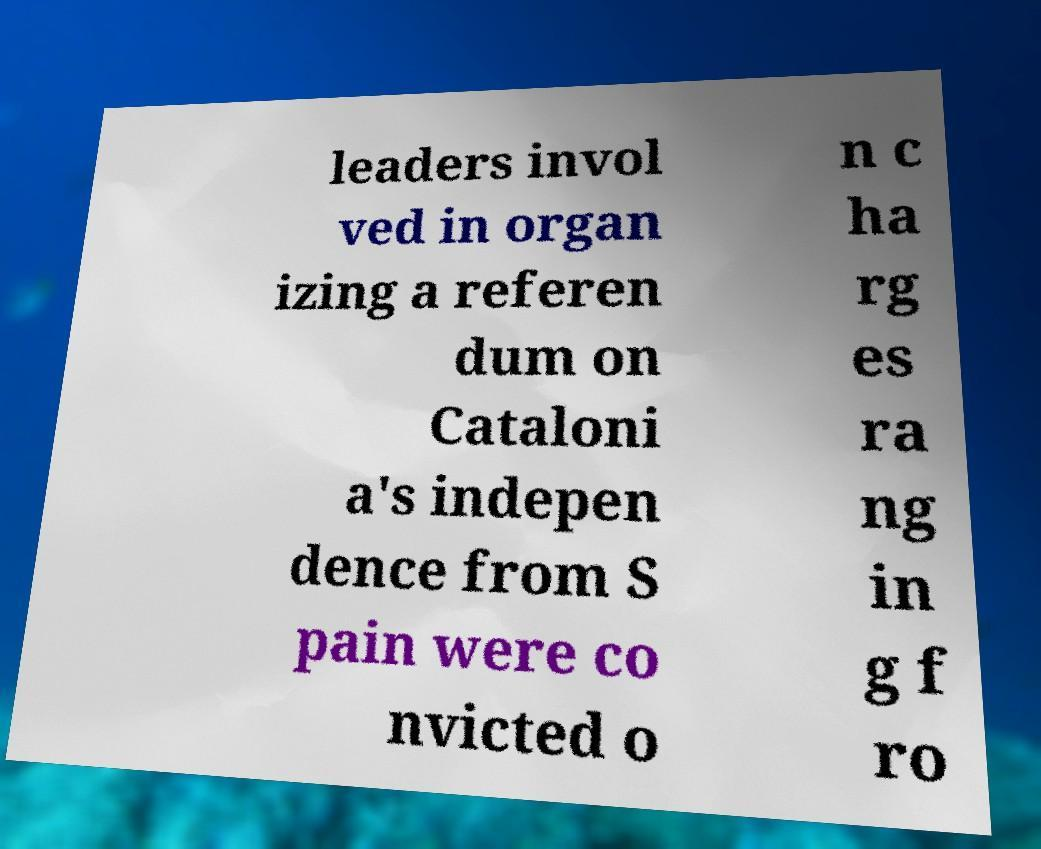There's text embedded in this image that I need extracted. Can you transcribe it verbatim? leaders invol ved in organ izing a referen dum on Cataloni a's indepen dence from S pain were co nvicted o n c ha rg es ra ng in g f ro 